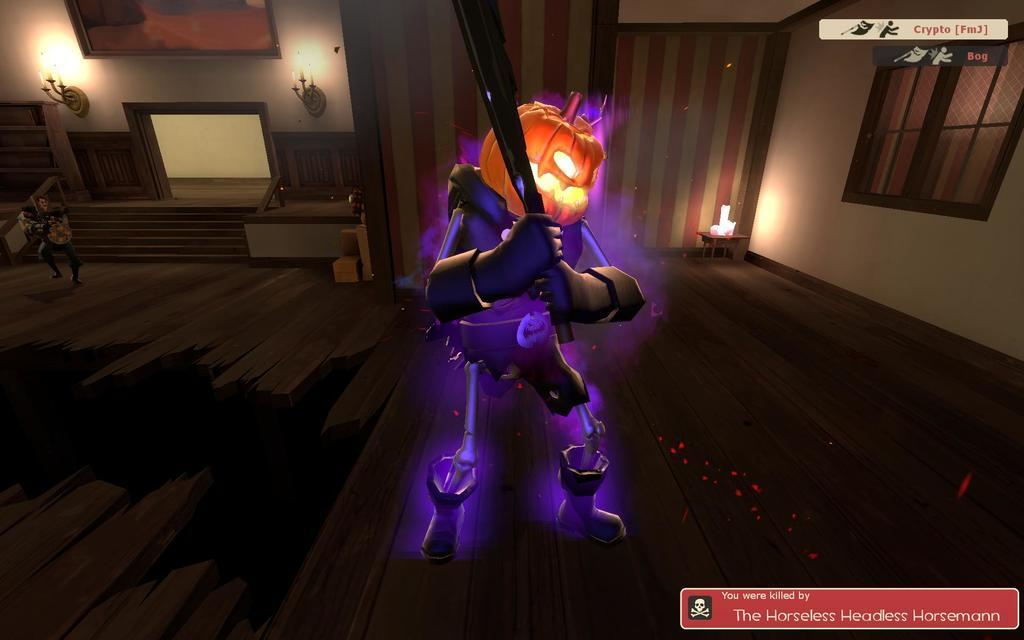What type of character is featured in the image? There is a robot with a pumpkin face in the image. Where is the robot located in the image? The robot is standing in the middle of a living room. What is happening on the left side of the image? There is a man walking on the left side of the image. Can you describe the man's position in relation to the steps? The man is in front of the steps. What type of fiction is the man reading in the image? There is no indication in the image that the man is reading any fiction. How many bananas can be seen in the image? There are no bananas present in the image. 